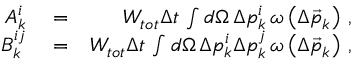<formula> <loc_0><loc_0><loc_500><loc_500>\begin{array} { r l r } { A _ { k } ^ { i } } & = } & { W _ { t o t } \Delta t \, \int d \Omega \, \Delta p _ { k } ^ { i } \, \omega \left ( \Delta \vec { p } _ { k } \right ) \, , } \\ { B _ { k } ^ { i j } } & = } & { W _ { t o t } \Delta t \, \int d \Omega \, \Delta p _ { k } ^ { i } \Delta p _ { k } ^ { j } \, \omega \left ( \Delta \vec { p } _ { k } \right ) \, , } \end{array}</formula> 